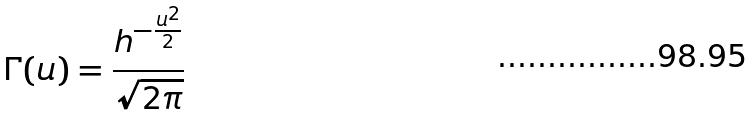Convert formula to latex. <formula><loc_0><loc_0><loc_500><loc_500>\Gamma ( u ) = \frac { h ^ { - \frac { u ^ { 2 } } { 2 } } } { \sqrt { 2 \pi } }</formula> 